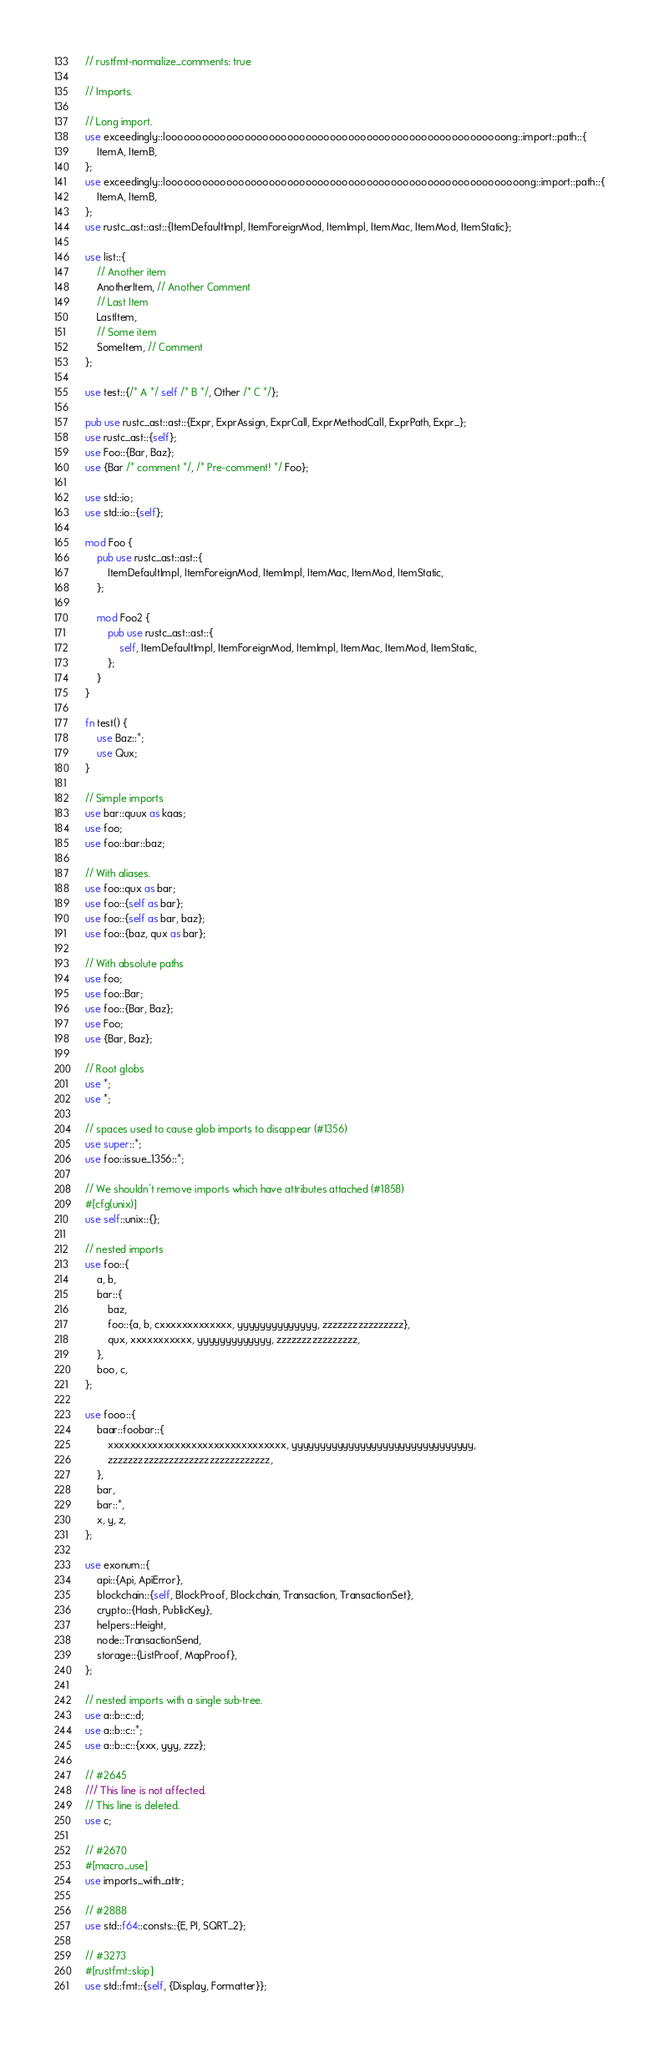Convert code to text. <code><loc_0><loc_0><loc_500><loc_500><_Rust_>// rustfmt-normalize_comments: true

// Imports.

// Long import.
use exceedingly::loooooooooooooooooooooooooooooooooooooooooooooooooooooooong::import::path::{
    ItemA, ItemB,
};
use exceedingly::looooooooooooooooooooooooooooooooooooooooooooooooooooooooooong::import::path::{
    ItemA, ItemB,
};
use rustc_ast::ast::{ItemDefaultImpl, ItemForeignMod, ItemImpl, ItemMac, ItemMod, ItemStatic};

use list::{
    // Another item
    AnotherItem, // Another Comment
    // Last Item
    LastItem,
    // Some item
    SomeItem, // Comment
};

use test::{/* A */ self /* B */, Other /* C */};

pub use rustc_ast::ast::{Expr, ExprAssign, ExprCall, ExprMethodCall, ExprPath, Expr_};
use rustc_ast::{self};
use Foo::{Bar, Baz};
use {Bar /* comment */, /* Pre-comment! */ Foo};

use std::io;
use std::io::{self};

mod Foo {
    pub use rustc_ast::ast::{
        ItemDefaultImpl, ItemForeignMod, ItemImpl, ItemMac, ItemMod, ItemStatic,
    };

    mod Foo2 {
        pub use rustc_ast::ast::{
            self, ItemDefaultImpl, ItemForeignMod, ItemImpl, ItemMac, ItemMod, ItemStatic,
        };
    }
}

fn test() {
    use Baz::*;
    use Qux;
}

// Simple imports
use bar::quux as kaas;
use foo;
use foo::bar::baz;

// With aliases.
use foo::qux as bar;
use foo::{self as bar};
use foo::{self as bar, baz};
use foo::{baz, qux as bar};

// With absolute paths
use foo;
use foo::Bar;
use foo::{Bar, Baz};
use Foo;
use {Bar, Baz};

// Root globs
use *;
use *;

// spaces used to cause glob imports to disappear (#1356)
use super::*;
use foo::issue_1356::*;

// We shouldn't remove imports which have attributes attached (#1858)
#[cfg(unix)]
use self::unix::{};

// nested imports
use foo::{
    a, b,
    bar::{
        baz,
        foo::{a, b, cxxxxxxxxxxxxx, yyyyyyyyyyyyyy, zzzzzzzzzzzzzzzz},
        qux, xxxxxxxxxxx, yyyyyyyyyyyyy, zzzzzzzzzzzzzzzz,
    },
    boo, c,
};

use fooo::{
    baar::foobar::{
        xxxxxxxxxxxxxxxxxxxxxxxxxxxxxxxx, yyyyyyyyyyyyyyyyyyyyyyyyyyyyyyyy,
        zzzzzzzzzzzzzzzzzzzzzzzzzzzzzzzz,
    },
    bar,
    bar::*,
    x, y, z,
};

use exonum::{
    api::{Api, ApiError},
    blockchain::{self, BlockProof, Blockchain, Transaction, TransactionSet},
    crypto::{Hash, PublicKey},
    helpers::Height,
    node::TransactionSend,
    storage::{ListProof, MapProof},
};

// nested imports with a single sub-tree.
use a::b::c::d;
use a::b::c::*;
use a::b::c::{xxx, yyy, zzz};

// #2645
/// This line is not affected.
// This line is deleted.
use c;

// #2670
#[macro_use]
use imports_with_attr;

// #2888
use std::f64::consts::{E, PI, SQRT_2};

// #3273
#[rustfmt::skip]
use std::fmt::{self, {Display, Formatter}};
</code> 